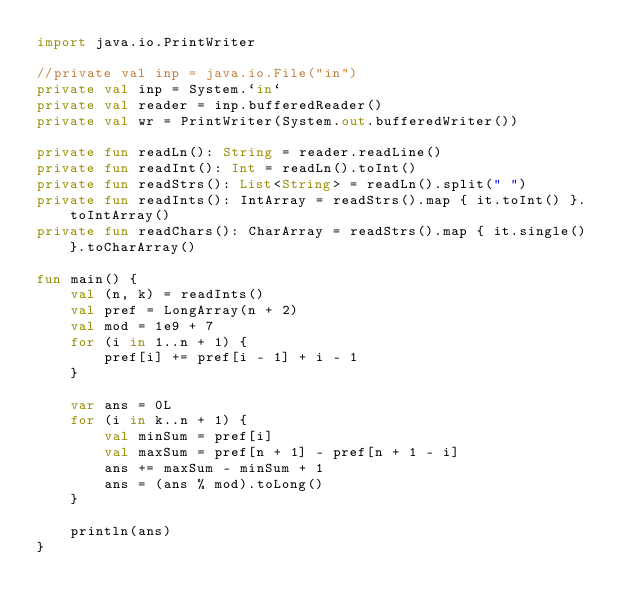<code> <loc_0><loc_0><loc_500><loc_500><_Kotlin_>import java.io.PrintWriter

//private val inp = java.io.File("in")
private val inp = System.`in`
private val reader = inp.bufferedReader()
private val wr = PrintWriter(System.out.bufferedWriter())

private fun readLn(): String = reader.readLine()
private fun readInt(): Int = readLn().toInt()
private fun readStrs(): List<String> = readLn().split(" ")
private fun readInts(): IntArray = readStrs().map { it.toInt() }.toIntArray()
private fun readChars(): CharArray = readStrs().map { it.single() }.toCharArray()

fun main() {
    val (n, k) = readInts()
    val pref = LongArray(n + 2)
    val mod = 1e9 + 7
    for (i in 1..n + 1) {
        pref[i] += pref[i - 1] + i - 1
    }

    var ans = 0L
    for (i in k..n + 1) {
        val minSum = pref[i]
        val maxSum = pref[n + 1] - pref[n + 1 - i]
        ans += maxSum - minSum + 1
        ans = (ans % mod).toLong()
    }

    println(ans)
}
</code> 